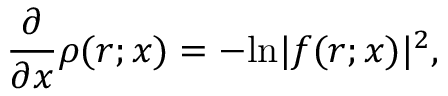<formula> <loc_0><loc_0><loc_500><loc_500>\frac { \partial } { \partial x } \rho ( r ; x ) = - \ln | f ( r ; x ) | ^ { 2 } ,</formula> 